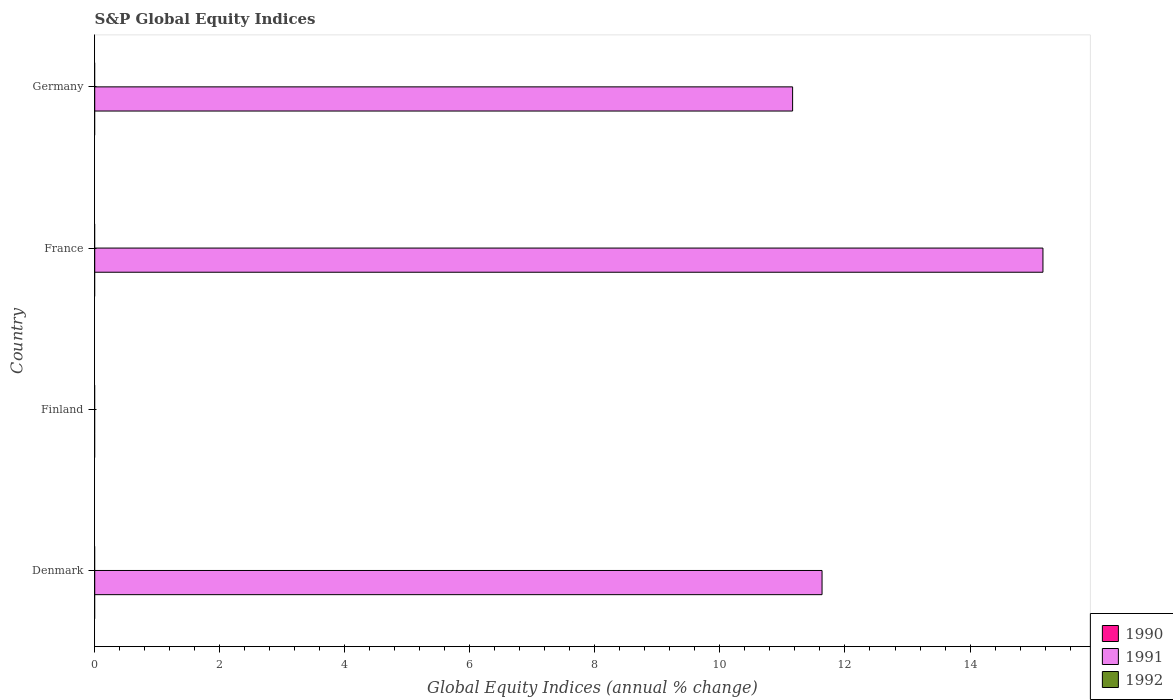Are the number of bars on each tick of the Y-axis equal?
Provide a short and direct response. No. How many bars are there on the 4th tick from the top?
Ensure brevity in your answer.  1. What is the global equity indices in 1990 in Germany?
Ensure brevity in your answer.  0. Across all countries, what is the maximum global equity indices in 1991?
Ensure brevity in your answer.  15.17. What is the difference between the global equity indices in 1991 in France and that in Germany?
Your response must be concise. 4. What is the difference between the global equity indices in 1991 in Denmark and the global equity indices in 1992 in Finland?
Provide a short and direct response. 11.63. What is the average global equity indices in 1992 per country?
Provide a short and direct response. 0. In how many countries, is the global equity indices in 1990 greater than 14 %?
Offer a very short reply. 0. What is the ratio of the global equity indices in 1991 in France to that in Germany?
Your answer should be very brief. 1.36. What is the difference between the highest and the second highest global equity indices in 1991?
Ensure brevity in your answer.  3.53. What is the difference between the highest and the lowest global equity indices in 1991?
Offer a terse response. 15.17. In how many countries, is the global equity indices in 1991 greater than the average global equity indices in 1991 taken over all countries?
Keep it short and to the point. 3. How many countries are there in the graph?
Provide a succinct answer. 4. What is the difference between two consecutive major ticks on the X-axis?
Provide a succinct answer. 2. Are the values on the major ticks of X-axis written in scientific E-notation?
Give a very brief answer. No. Does the graph contain any zero values?
Give a very brief answer. Yes. Does the graph contain grids?
Keep it short and to the point. No. Where does the legend appear in the graph?
Your answer should be very brief. Bottom right. How are the legend labels stacked?
Offer a terse response. Vertical. What is the title of the graph?
Provide a succinct answer. S&P Global Equity Indices. Does "2012" appear as one of the legend labels in the graph?
Your answer should be compact. No. What is the label or title of the X-axis?
Offer a very short reply. Global Equity Indices (annual % change). What is the Global Equity Indices (annual % change) of 1990 in Denmark?
Your response must be concise. 0. What is the Global Equity Indices (annual % change) of 1991 in Denmark?
Offer a terse response. 11.63. What is the Global Equity Indices (annual % change) of 1990 in France?
Give a very brief answer. 0. What is the Global Equity Indices (annual % change) of 1991 in France?
Ensure brevity in your answer.  15.17. What is the Global Equity Indices (annual % change) of 1991 in Germany?
Your answer should be very brief. 11.16. Across all countries, what is the maximum Global Equity Indices (annual % change) in 1991?
Give a very brief answer. 15.17. Across all countries, what is the minimum Global Equity Indices (annual % change) in 1991?
Your answer should be very brief. 0. What is the total Global Equity Indices (annual % change) in 1991 in the graph?
Your answer should be compact. 37.96. What is the total Global Equity Indices (annual % change) in 1992 in the graph?
Your answer should be very brief. 0. What is the difference between the Global Equity Indices (annual % change) of 1991 in Denmark and that in France?
Your response must be concise. -3.53. What is the difference between the Global Equity Indices (annual % change) of 1991 in Denmark and that in Germany?
Your answer should be compact. 0.47. What is the difference between the Global Equity Indices (annual % change) of 1991 in France and that in Germany?
Keep it short and to the point. 4. What is the average Global Equity Indices (annual % change) in 1990 per country?
Your response must be concise. 0. What is the average Global Equity Indices (annual % change) in 1991 per country?
Give a very brief answer. 9.49. What is the average Global Equity Indices (annual % change) in 1992 per country?
Offer a very short reply. 0. What is the ratio of the Global Equity Indices (annual % change) of 1991 in Denmark to that in France?
Give a very brief answer. 0.77. What is the ratio of the Global Equity Indices (annual % change) of 1991 in Denmark to that in Germany?
Ensure brevity in your answer.  1.04. What is the ratio of the Global Equity Indices (annual % change) of 1991 in France to that in Germany?
Provide a succinct answer. 1.36. What is the difference between the highest and the second highest Global Equity Indices (annual % change) of 1991?
Ensure brevity in your answer.  3.53. What is the difference between the highest and the lowest Global Equity Indices (annual % change) in 1991?
Offer a terse response. 15.17. 